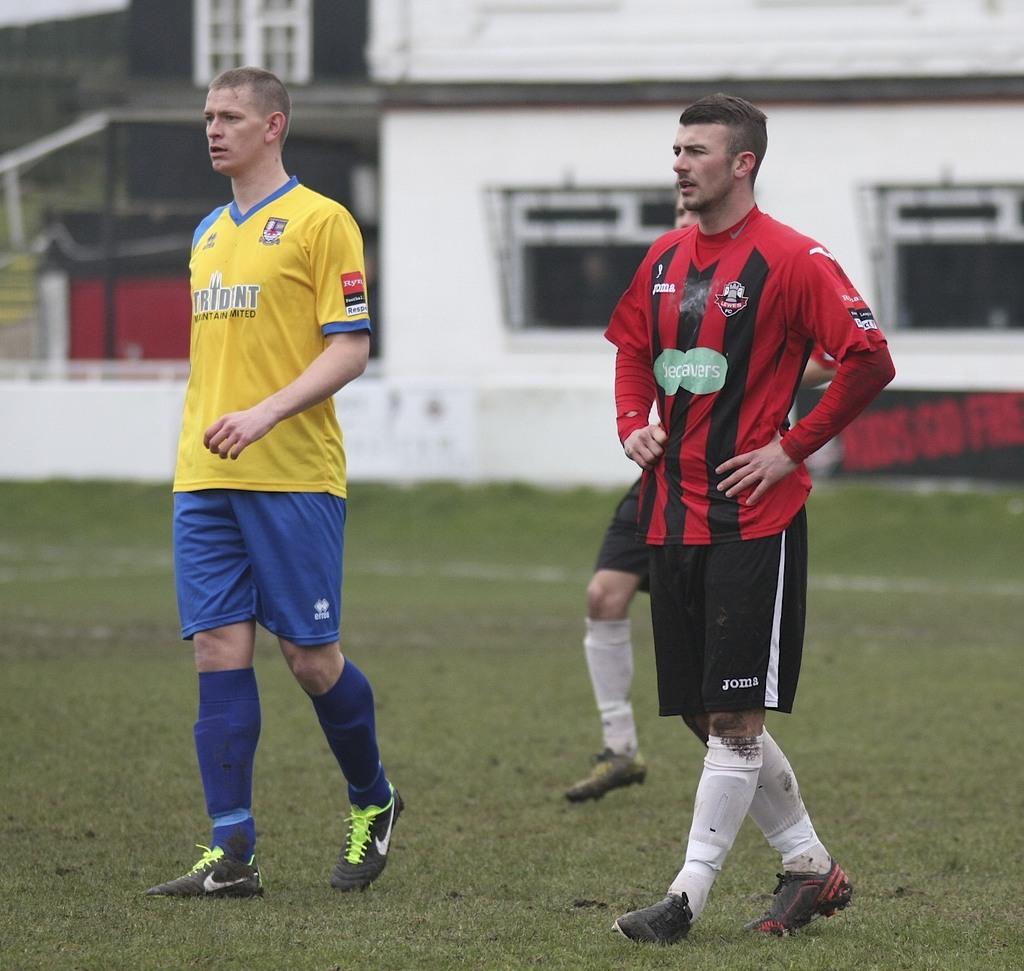What team is the player in yellow playing for?
Give a very brief answer. Unanswerable. 